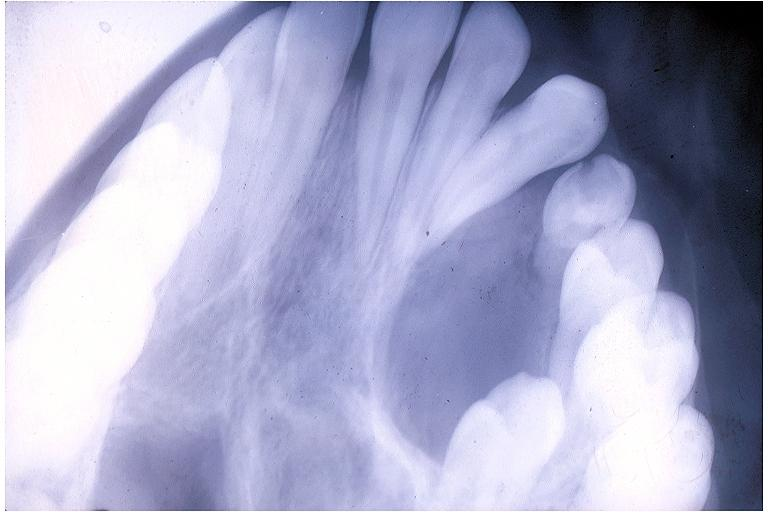does metastatic adenocarcinoma show adenomatoid odontogenic tumor?
Answer the question using a single word or phrase. No 